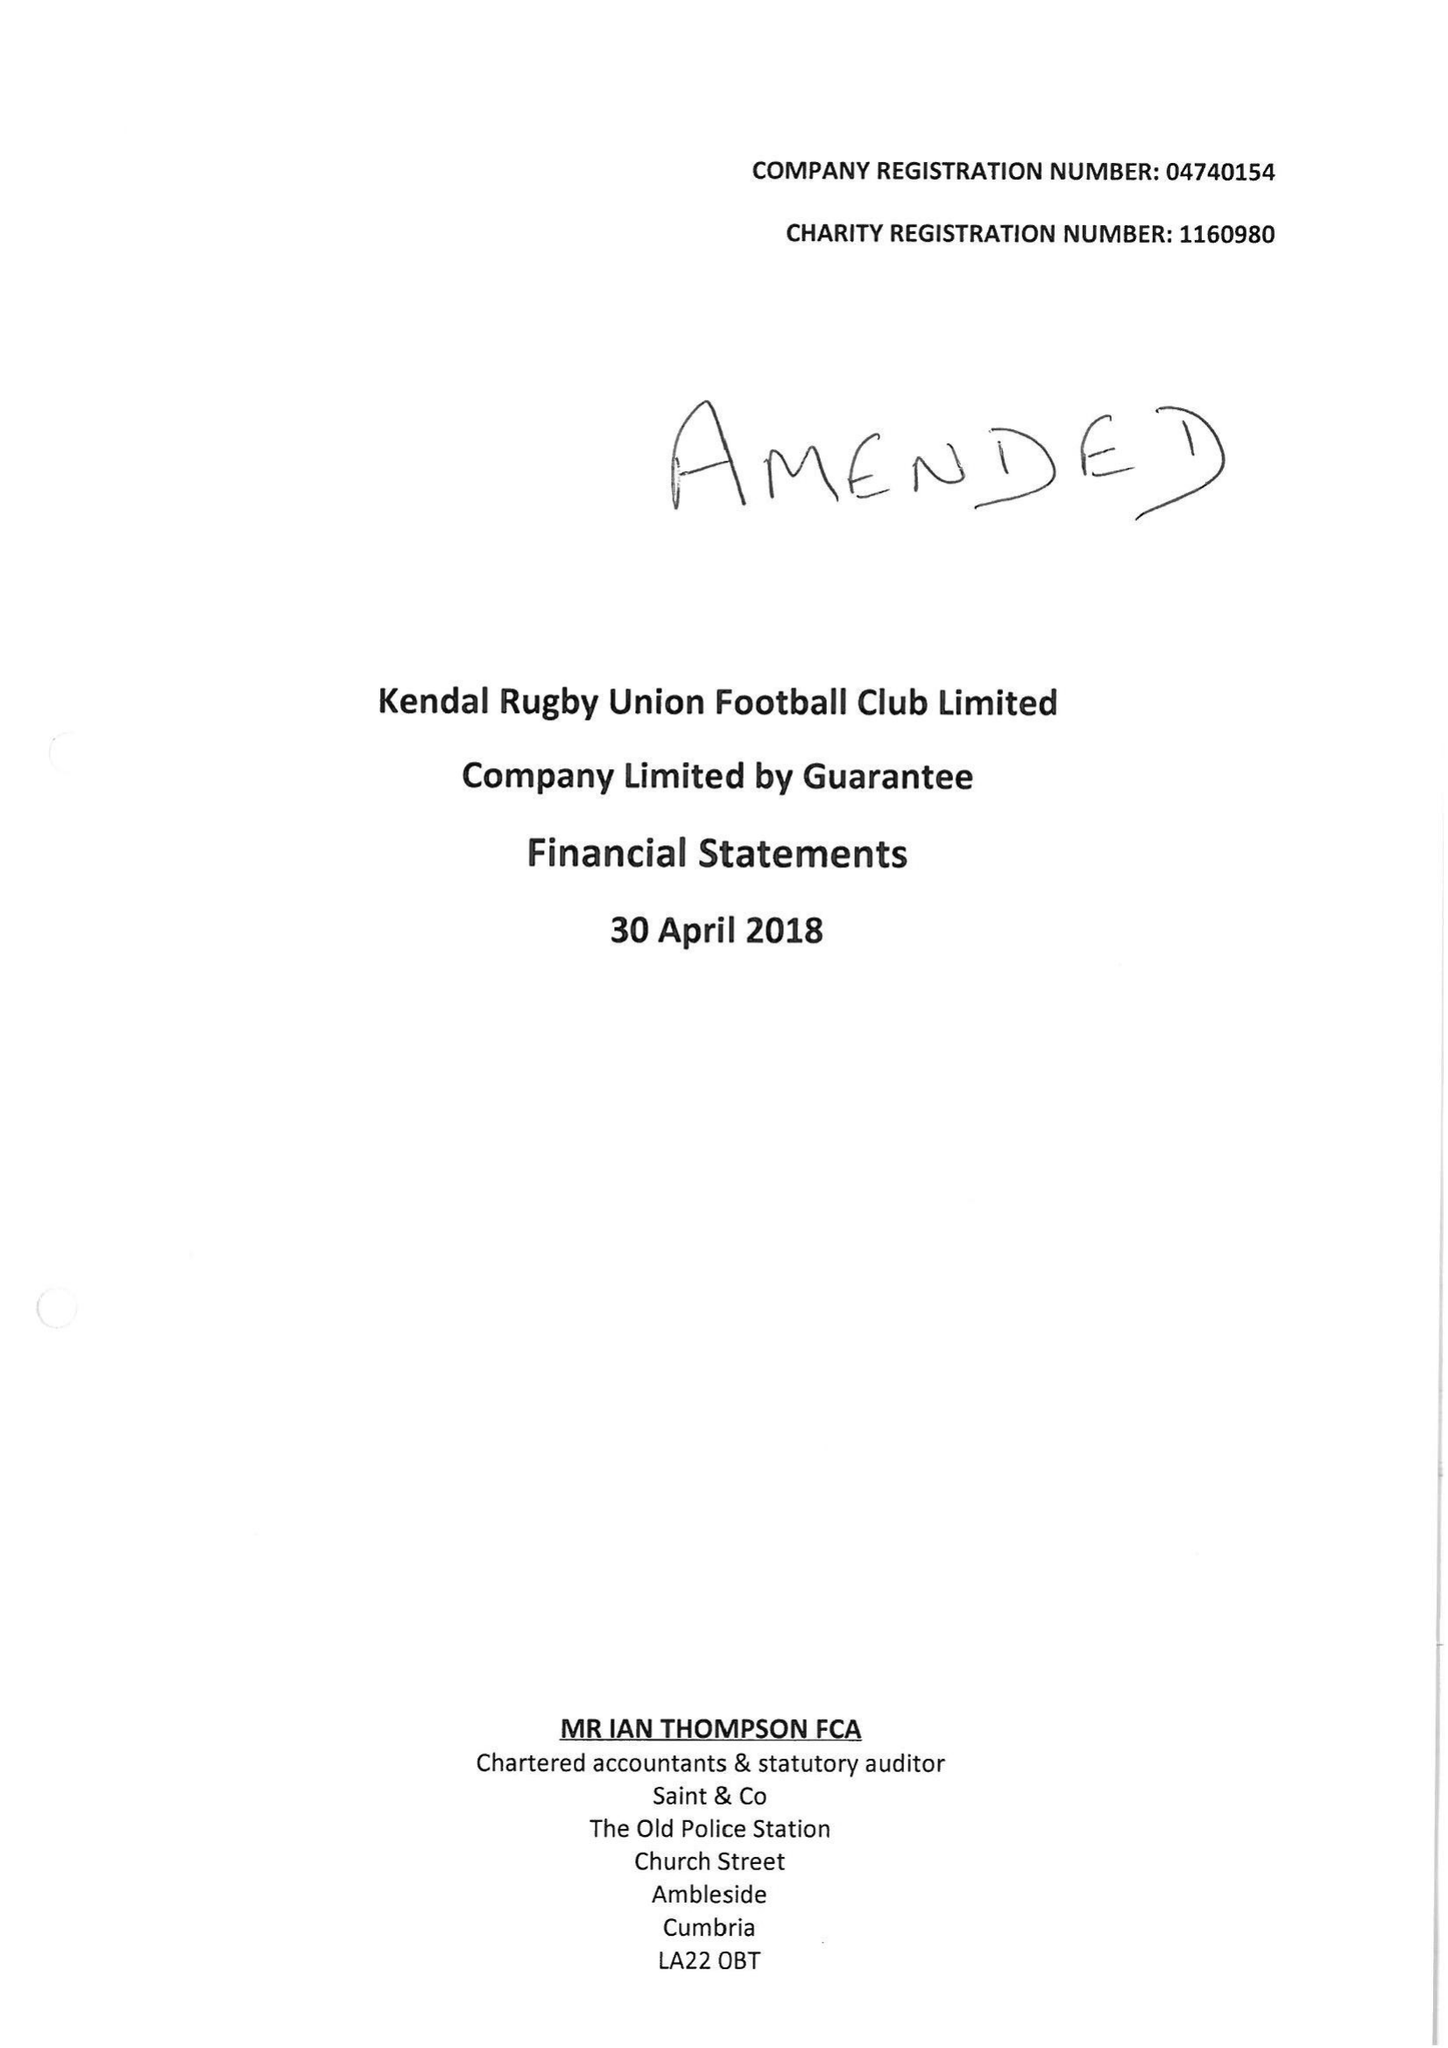What is the value for the income_annually_in_british_pounds?
Answer the question using a single word or phrase. 10347886.00 